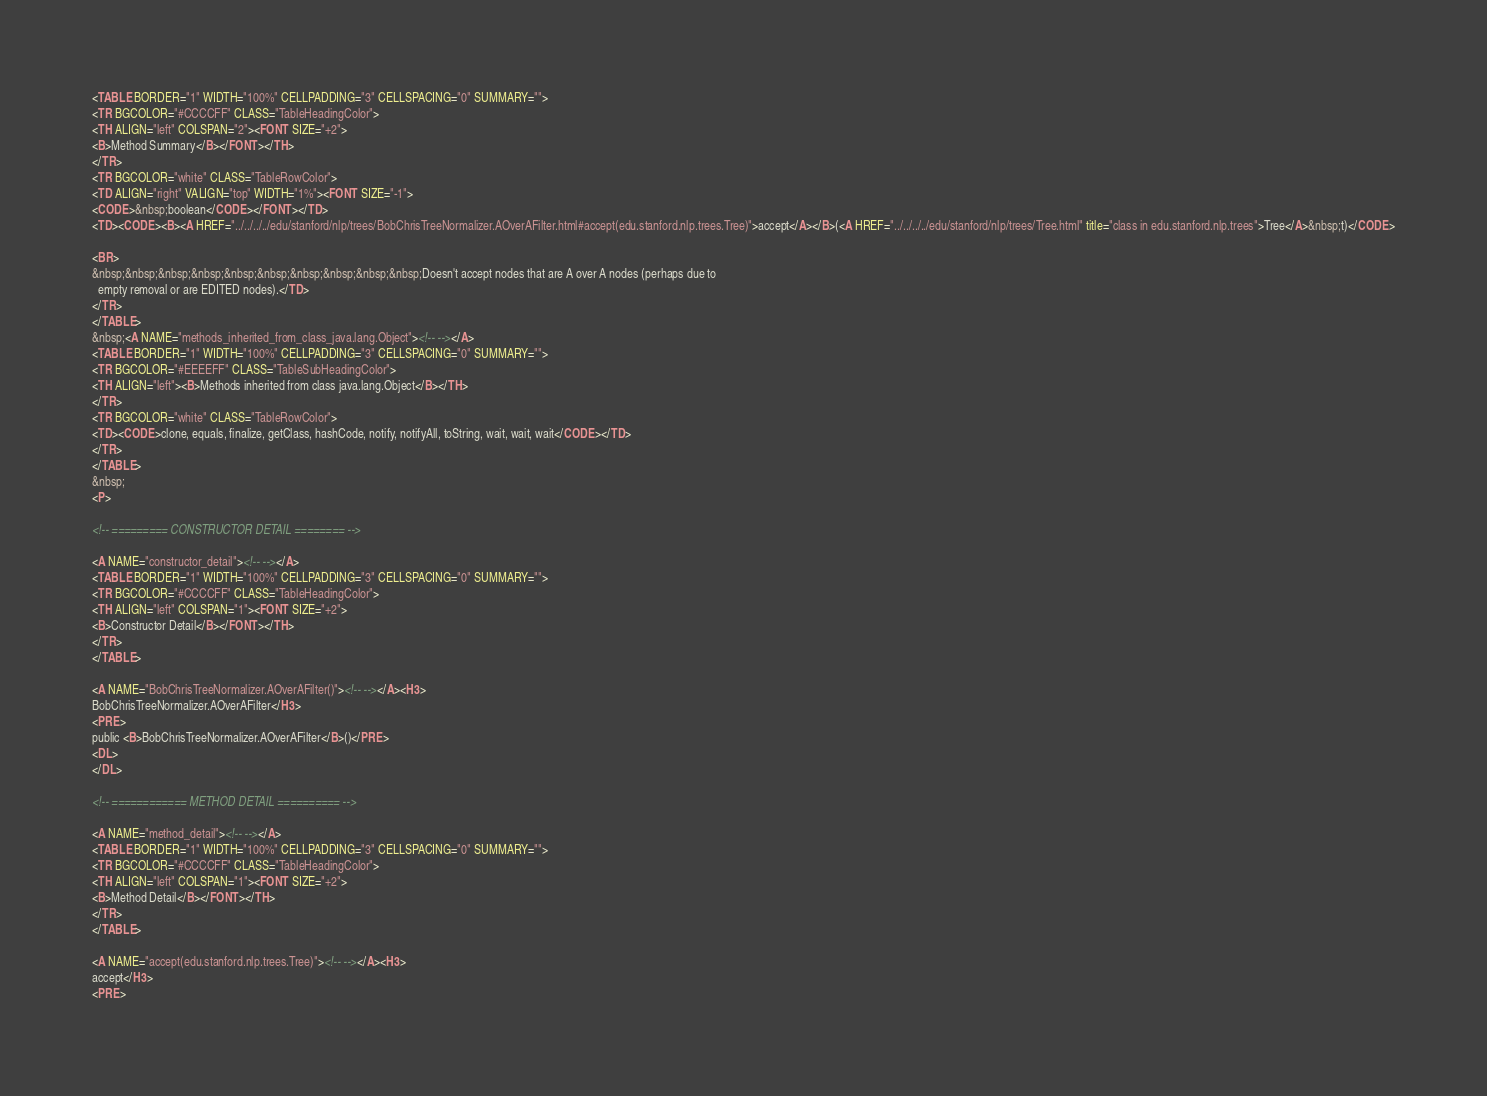<code> <loc_0><loc_0><loc_500><loc_500><_HTML_><TABLE BORDER="1" WIDTH="100%" CELLPADDING="3" CELLSPACING="0" SUMMARY="">
<TR BGCOLOR="#CCCCFF" CLASS="TableHeadingColor">
<TH ALIGN="left" COLSPAN="2"><FONT SIZE="+2">
<B>Method Summary</B></FONT></TH>
</TR>
<TR BGCOLOR="white" CLASS="TableRowColor">
<TD ALIGN="right" VALIGN="top" WIDTH="1%"><FONT SIZE="-1">
<CODE>&nbsp;boolean</CODE></FONT></TD>
<TD><CODE><B><A HREF="../../../../edu/stanford/nlp/trees/BobChrisTreeNormalizer.AOverAFilter.html#accept(edu.stanford.nlp.trees.Tree)">accept</A></B>(<A HREF="../../../../edu/stanford/nlp/trees/Tree.html" title="class in edu.stanford.nlp.trees">Tree</A>&nbsp;t)</CODE>

<BR>
&nbsp;&nbsp;&nbsp;&nbsp;&nbsp;&nbsp;&nbsp;&nbsp;&nbsp;&nbsp;Doesn't accept nodes that are A over A nodes (perhaps due to
  empty removal or are EDITED nodes).</TD>
</TR>
</TABLE>
&nbsp;<A NAME="methods_inherited_from_class_java.lang.Object"><!-- --></A>
<TABLE BORDER="1" WIDTH="100%" CELLPADDING="3" CELLSPACING="0" SUMMARY="">
<TR BGCOLOR="#EEEEFF" CLASS="TableSubHeadingColor">
<TH ALIGN="left"><B>Methods inherited from class java.lang.Object</B></TH>
</TR>
<TR BGCOLOR="white" CLASS="TableRowColor">
<TD><CODE>clone, equals, finalize, getClass, hashCode, notify, notifyAll, toString, wait, wait, wait</CODE></TD>
</TR>
</TABLE>
&nbsp;
<P>

<!-- ========= CONSTRUCTOR DETAIL ======== -->

<A NAME="constructor_detail"><!-- --></A>
<TABLE BORDER="1" WIDTH="100%" CELLPADDING="3" CELLSPACING="0" SUMMARY="">
<TR BGCOLOR="#CCCCFF" CLASS="TableHeadingColor">
<TH ALIGN="left" COLSPAN="1"><FONT SIZE="+2">
<B>Constructor Detail</B></FONT></TH>
</TR>
</TABLE>

<A NAME="BobChrisTreeNormalizer.AOverAFilter()"><!-- --></A><H3>
BobChrisTreeNormalizer.AOverAFilter</H3>
<PRE>
public <B>BobChrisTreeNormalizer.AOverAFilter</B>()</PRE>
<DL>
</DL>

<!-- ============ METHOD DETAIL ========== -->

<A NAME="method_detail"><!-- --></A>
<TABLE BORDER="1" WIDTH="100%" CELLPADDING="3" CELLSPACING="0" SUMMARY="">
<TR BGCOLOR="#CCCCFF" CLASS="TableHeadingColor">
<TH ALIGN="left" COLSPAN="1"><FONT SIZE="+2">
<B>Method Detail</B></FONT></TH>
</TR>
</TABLE>

<A NAME="accept(edu.stanford.nlp.trees.Tree)"><!-- --></A><H3>
accept</H3>
<PRE></code> 